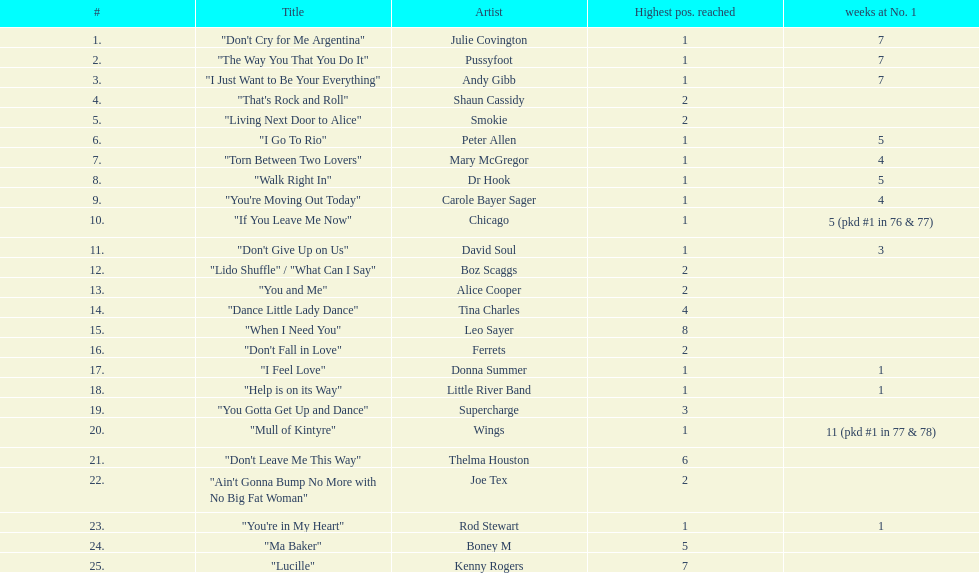How many songs in the table only reached position number 2? 6. 